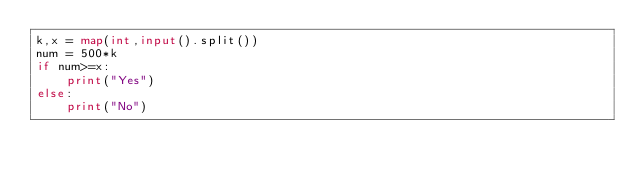Convert code to text. <code><loc_0><loc_0><loc_500><loc_500><_Python_>k,x = map(int,input().split())
num = 500*k
if num>=x:
    print("Yes")
else:
    print("No")</code> 